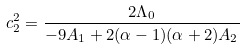<formula> <loc_0><loc_0><loc_500><loc_500>c _ { 2 } ^ { 2 } = \frac { 2 \Lambda _ { 0 } } { - 9 A _ { 1 } + 2 ( \alpha - 1 ) ( \alpha + 2 ) A _ { 2 } }</formula> 